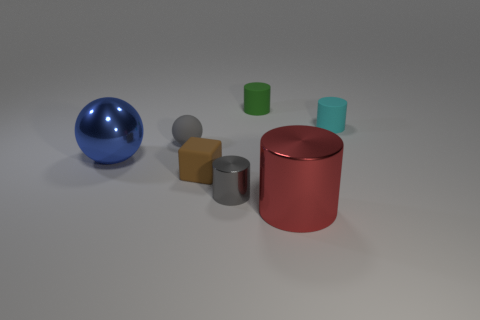Add 2 gray objects. How many objects exist? 9 Subtract all big red cylinders. How many cylinders are left? 3 Subtract 1 cubes. How many cubes are left? 0 Add 4 metal objects. How many metal objects are left? 7 Add 5 brown things. How many brown things exist? 6 Subtract all gray cylinders. How many cylinders are left? 3 Subtract 0 green balls. How many objects are left? 7 Subtract all cylinders. How many objects are left? 3 Subtract all red cubes. Subtract all purple spheres. How many cubes are left? 1 Subtract all yellow cylinders. How many yellow balls are left? 0 